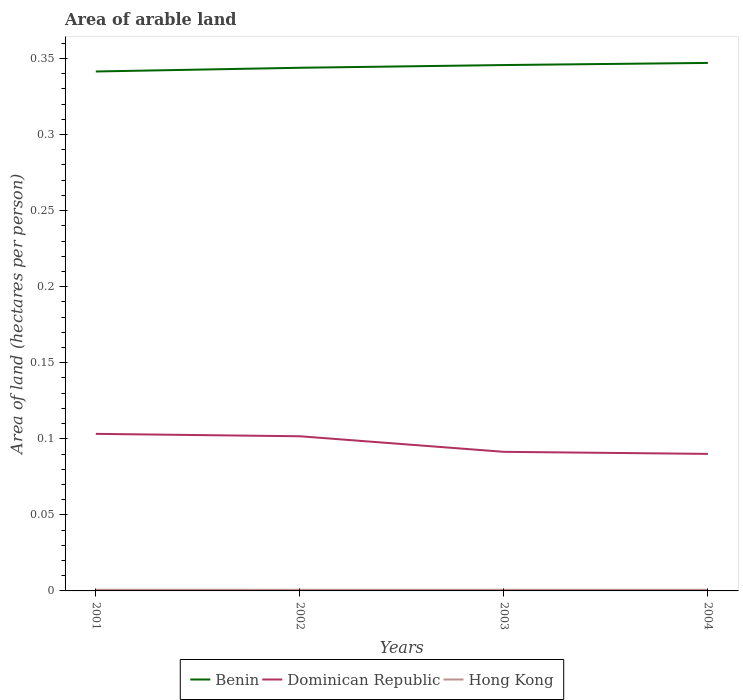How many different coloured lines are there?
Provide a succinct answer. 3. Does the line corresponding to Benin intersect with the line corresponding to Dominican Republic?
Ensure brevity in your answer.  No. Across all years, what is the maximum total arable land in Dominican Republic?
Your answer should be very brief. 0.09. What is the total total arable land in Hong Kong in the graph?
Make the answer very short. 7.596639677375752e-6. What is the difference between the highest and the second highest total arable land in Dominican Republic?
Offer a terse response. 0.01. Is the total arable land in Hong Kong strictly greater than the total arable land in Benin over the years?
Provide a short and direct response. Yes. What is the difference between two consecutive major ticks on the Y-axis?
Keep it short and to the point. 0.05. Does the graph contain grids?
Your response must be concise. No. How are the legend labels stacked?
Your response must be concise. Horizontal. What is the title of the graph?
Offer a very short reply. Area of arable land. What is the label or title of the Y-axis?
Make the answer very short. Area of land (hectares per person). What is the Area of land (hectares per person) of Benin in 2001?
Your answer should be compact. 0.34. What is the Area of land (hectares per person) of Dominican Republic in 2001?
Make the answer very short. 0.1. What is the Area of land (hectares per person) in Hong Kong in 2001?
Your answer should be compact. 0. What is the Area of land (hectares per person) of Benin in 2002?
Offer a terse response. 0.34. What is the Area of land (hectares per person) in Dominican Republic in 2002?
Your answer should be very brief. 0.1. What is the Area of land (hectares per person) in Hong Kong in 2002?
Ensure brevity in your answer.  0. What is the Area of land (hectares per person) of Benin in 2003?
Give a very brief answer. 0.35. What is the Area of land (hectares per person) of Dominican Republic in 2003?
Offer a very short reply. 0.09. What is the Area of land (hectares per person) in Hong Kong in 2003?
Your answer should be compact. 0. What is the Area of land (hectares per person) of Benin in 2004?
Make the answer very short. 0.35. What is the Area of land (hectares per person) in Dominican Republic in 2004?
Keep it short and to the point. 0.09. What is the Area of land (hectares per person) of Hong Kong in 2004?
Offer a terse response. 0. Across all years, what is the maximum Area of land (hectares per person) of Benin?
Your answer should be very brief. 0.35. Across all years, what is the maximum Area of land (hectares per person) of Dominican Republic?
Your answer should be very brief. 0.1. Across all years, what is the maximum Area of land (hectares per person) in Hong Kong?
Your answer should be compact. 0. Across all years, what is the minimum Area of land (hectares per person) in Benin?
Your answer should be very brief. 0.34. Across all years, what is the minimum Area of land (hectares per person) in Dominican Republic?
Provide a succinct answer. 0.09. Across all years, what is the minimum Area of land (hectares per person) of Hong Kong?
Your answer should be compact. 0. What is the total Area of land (hectares per person) in Benin in the graph?
Your response must be concise. 1.38. What is the total Area of land (hectares per person) in Dominican Republic in the graph?
Ensure brevity in your answer.  0.39. What is the total Area of land (hectares per person) in Hong Kong in the graph?
Make the answer very short. 0. What is the difference between the Area of land (hectares per person) in Benin in 2001 and that in 2002?
Ensure brevity in your answer.  -0. What is the difference between the Area of land (hectares per person) in Dominican Republic in 2001 and that in 2002?
Your answer should be compact. 0. What is the difference between the Area of land (hectares per person) of Hong Kong in 2001 and that in 2002?
Your response must be concise. 0. What is the difference between the Area of land (hectares per person) in Benin in 2001 and that in 2003?
Your answer should be very brief. -0. What is the difference between the Area of land (hectares per person) of Dominican Republic in 2001 and that in 2003?
Ensure brevity in your answer.  0.01. What is the difference between the Area of land (hectares per person) in Benin in 2001 and that in 2004?
Your answer should be compact. -0.01. What is the difference between the Area of land (hectares per person) of Dominican Republic in 2001 and that in 2004?
Make the answer very short. 0.01. What is the difference between the Area of land (hectares per person) in Hong Kong in 2001 and that in 2004?
Ensure brevity in your answer.  0. What is the difference between the Area of land (hectares per person) in Benin in 2002 and that in 2003?
Your answer should be very brief. -0. What is the difference between the Area of land (hectares per person) of Dominican Republic in 2002 and that in 2003?
Provide a short and direct response. 0.01. What is the difference between the Area of land (hectares per person) of Benin in 2002 and that in 2004?
Offer a terse response. -0. What is the difference between the Area of land (hectares per person) of Dominican Republic in 2002 and that in 2004?
Provide a short and direct response. 0.01. What is the difference between the Area of land (hectares per person) of Benin in 2003 and that in 2004?
Your response must be concise. -0. What is the difference between the Area of land (hectares per person) in Dominican Republic in 2003 and that in 2004?
Give a very brief answer. 0. What is the difference between the Area of land (hectares per person) in Hong Kong in 2003 and that in 2004?
Give a very brief answer. 0. What is the difference between the Area of land (hectares per person) of Benin in 2001 and the Area of land (hectares per person) of Dominican Republic in 2002?
Offer a terse response. 0.24. What is the difference between the Area of land (hectares per person) in Benin in 2001 and the Area of land (hectares per person) in Hong Kong in 2002?
Give a very brief answer. 0.34. What is the difference between the Area of land (hectares per person) in Dominican Republic in 2001 and the Area of land (hectares per person) in Hong Kong in 2002?
Offer a terse response. 0.1. What is the difference between the Area of land (hectares per person) of Benin in 2001 and the Area of land (hectares per person) of Dominican Republic in 2003?
Provide a short and direct response. 0.25. What is the difference between the Area of land (hectares per person) of Benin in 2001 and the Area of land (hectares per person) of Hong Kong in 2003?
Your answer should be very brief. 0.34. What is the difference between the Area of land (hectares per person) in Dominican Republic in 2001 and the Area of land (hectares per person) in Hong Kong in 2003?
Keep it short and to the point. 0.1. What is the difference between the Area of land (hectares per person) in Benin in 2001 and the Area of land (hectares per person) in Dominican Republic in 2004?
Your answer should be very brief. 0.25. What is the difference between the Area of land (hectares per person) in Benin in 2001 and the Area of land (hectares per person) in Hong Kong in 2004?
Make the answer very short. 0.34. What is the difference between the Area of land (hectares per person) in Dominican Republic in 2001 and the Area of land (hectares per person) in Hong Kong in 2004?
Provide a short and direct response. 0.1. What is the difference between the Area of land (hectares per person) of Benin in 2002 and the Area of land (hectares per person) of Dominican Republic in 2003?
Ensure brevity in your answer.  0.25. What is the difference between the Area of land (hectares per person) in Benin in 2002 and the Area of land (hectares per person) in Hong Kong in 2003?
Your response must be concise. 0.34. What is the difference between the Area of land (hectares per person) in Dominican Republic in 2002 and the Area of land (hectares per person) in Hong Kong in 2003?
Your answer should be very brief. 0.1. What is the difference between the Area of land (hectares per person) in Benin in 2002 and the Area of land (hectares per person) in Dominican Republic in 2004?
Provide a succinct answer. 0.25. What is the difference between the Area of land (hectares per person) of Benin in 2002 and the Area of land (hectares per person) of Hong Kong in 2004?
Your answer should be very brief. 0.34. What is the difference between the Area of land (hectares per person) in Dominican Republic in 2002 and the Area of land (hectares per person) in Hong Kong in 2004?
Provide a succinct answer. 0.1. What is the difference between the Area of land (hectares per person) of Benin in 2003 and the Area of land (hectares per person) of Dominican Republic in 2004?
Offer a terse response. 0.26. What is the difference between the Area of land (hectares per person) of Benin in 2003 and the Area of land (hectares per person) of Hong Kong in 2004?
Provide a short and direct response. 0.34. What is the difference between the Area of land (hectares per person) of Dominican Republic in 2003 and the Area of land (hectares per person) of Hong Kong in 2004?
Keep it short and to the point. 0.09. What is the average Area of land (hectares per person) of Benin per year?
Give a very brief answer. 0.34. What is the average Area of land (hectares per person) of Dominican Republic per year?
Provide a succinct answer. 0.1. What is the average Area of land (hectares per person) in Hong Kong per year?
Provide a succinct answer. 0. In the year 2001, what is the difference between the Area of land (hectares per person) of Benin and Area of land (hectares per person) of Dominican Republic?
Keep it short and to the point. 0.24. In the year 2001, what is the difference between the Area of land (hectares per person) of Benin and Area of land (hectares per person) of Hong Kong?
Keep it short and to the point. 0.34. In the year 2001, what is the difference between the Area of land (hectares per person) of Dominican Republic and Area of land (hectares per person) of Hong Kong?
Make the answer very short. 0.1. In the year 2002, what is the difference between the Area of land (hectares per person) in Benin and Area of land (hectares per person) in Dominican Republic?
Offer a terse response. 0.24. In the year 2002, what is the difference between the Area of land (hectares per person) of Benin and Area of land (hectares per person) of Hong Kong?
Your response must be concise. 0.34. In the year 2002, what is the difference between the Area of land (hectares per person) of Dominican Republic and Area of land (hectares per person) of Hong Kong?
Provide a short and direct response. 0.1. In the year 2003, what is the difference between the Area of land (hectares per person) in Benin and Area of land (hectares per person) in Dominican Republic?
Your response must be concise. 0.25. In the year 2003, what is the difference between the Area of land (hectares per person) in Benin and Area of land (hectares per person) in Hong Kong?
Make the answer very short. 0.34. In the year 2003, what is the difference between the Area of land (hectares per person) in Dominican Republic and Area of land (hectares per person) in Hong Kong?
Provide a succinct answer. 0.09. In the year 2004, what is the difference between the Area of land (hectares per person) in Benin and Area of land (hectares per person) in Dominican Republic?
Offer a terse response. 0.26. In the year 2004, what is the difference between the Area of land (hectares per person) in Benin and Area of land (hectares per person) in Hong Kong?
Offer a terse response. 0.35. In the year 2004, what is the difference between the Area of land (hectares per person) in Dominican Republic and Area of land (hectares per person) in Hong Kong?
Your answer should be compact. 0.09. What is the ratio of the Area of land (hectares per person) in Benin in 2001 to that in 2002?
Your response must be concise. 0.99. What is the ratio of the Area of land (hectares per person) in Dominican Republic in 2001 to that in 2002?
Offer a terse response. 1.02. What is the ratio of the Area of land (hectares per person) in Hong Kong in 2001 to that in 2002?
Offer a terse response. 1. What is the ratio of the Area of land (hectares per person) of Benin in 2001 to that in 2003?
Provide a succinct answer. 0.99. What is the ratio of the Area of land (hectares per person) of Dominican Republic in 2001 to that in 2003?
Give a very brief answer. 1.13. What is the ratio of the Area of land (hectares per person) in Hong Kong in 2001 to that in 2003?
Offer a very short reply. 1. What is the ratio of the Area of land (hectares per person) of Benin in 2001 to that in 2004?
Give a very brief answer. 0.98. What is the ratio of the Area of land (hectares per person) in Dominican Republic in 2001 to that in 2004?
Give a very brief answer. 1.15. What is the ratio of the Area of land (hectares per person) in Hong Kong in 2001 to that in 2004?
Provide a short and direct response. 1.01. What is the ratio of the Area of land (hectares per person) of Dominican Republic in 2002 to that in 2003?
Your answer should be very brief. 1.11. What is the ratio of the Area of land (hectares per person) in Benin in 2002 to that in 2004?
Make the answer very short. 0.99. What is the ratio of the Area of land (hectares per person) of Dominican Republic in 2002 to that in 2004?
Provide a succinct answer. 1.13. What is the ratio of the Area of land (hectares per person) of Hong Kong in 2002 to that in 2004?
Provide a short and direct response. 1.01. What is the ratio of the Area of land (hectares per person) of Dominican Republic in 2003 to that in 2004?
Your response must be concise. 1.02. What is the difference between the highest and the second highest Area of land (hectares per person) in Benin?
Ensure brevity in your answer.  0. What is the difference between the highest and the second highest Area of land (hectares per person) in Dominican Republic?
Offer a very short reply. 0. What is the difference between the highest and the second highest Area of land (hectares per person) in Hong Kong?
Ensure brevity in your answer.  0. What is the difference between the highest and the lowest Area of land (hectares per person) of Benin?
Ensure brevity in your answer.  0.01. What is the difference between the highest and the lowest Area of land (hectares per person) of Dominican Republic?
Your response must be concise. 0.01. What is the difference between the highest and the lowest Area of land (hectares per person) of Hong Kong?
Offer a very short reply. 0. 